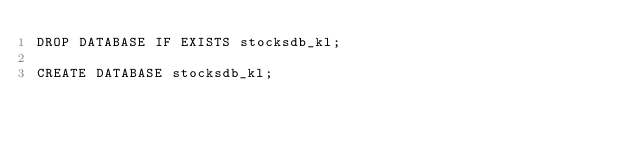Convert code to text. <code><loc_0><loc_0><loc_500><loc_500><_SQL_>DROP DATABASE IF EXISTS stocksdb_kl;

CREATE DATABASE stocksdb_kl;</code> 